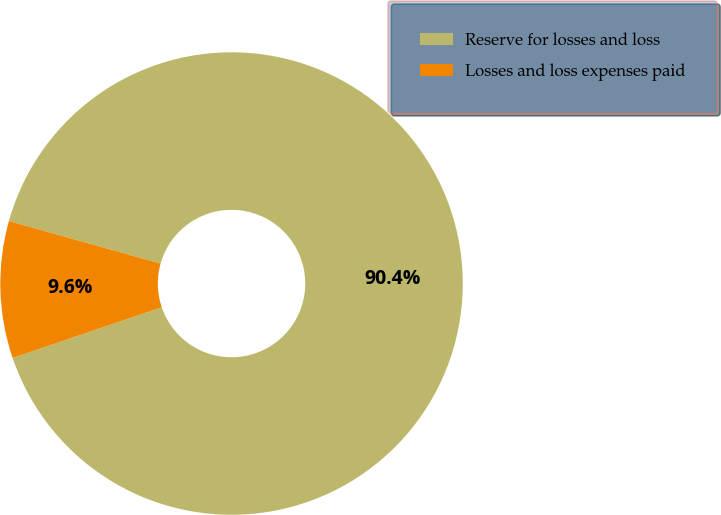Convert chart to OTSL. <chart><loc_0><loc_0><loc_500><loc_500><pie_chart><fcel>Reserve for losses and loss<fcel>Losses and loss expenses paid<nl><fcel>90.42%<fcel>9.58%<nl></chart> 